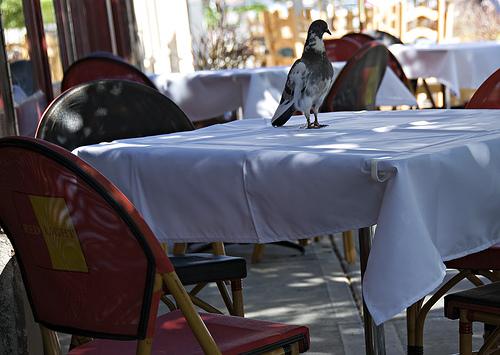Are there any people at the tables?
Keep it brief. No. Why would the bird hang out at a restaurant?
Keep it brief. Food. Is the bird waiting to be seated?
Short answer required. No. 